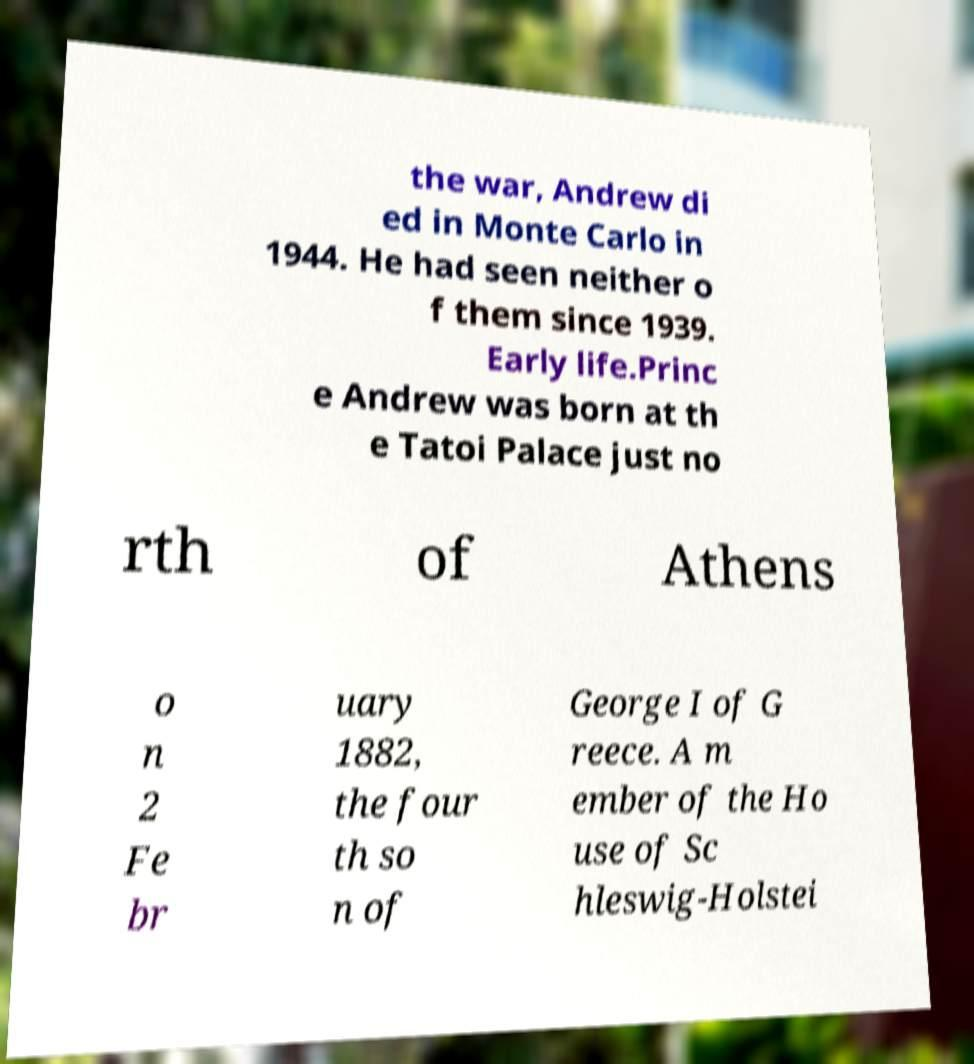Please identify and transcribe the text found in this image. the war, Andrew di ed in Monte Carlo in 1944. He had seen neither o f them since 1939. Early life.Princ e Andrew was born at th e Tatoi Palace just no rth of Athens o n 2 Fe br uary 1882, the four th so n of George I of G reece. A m ember of the Ho use of Sc hleswig-Holstei 